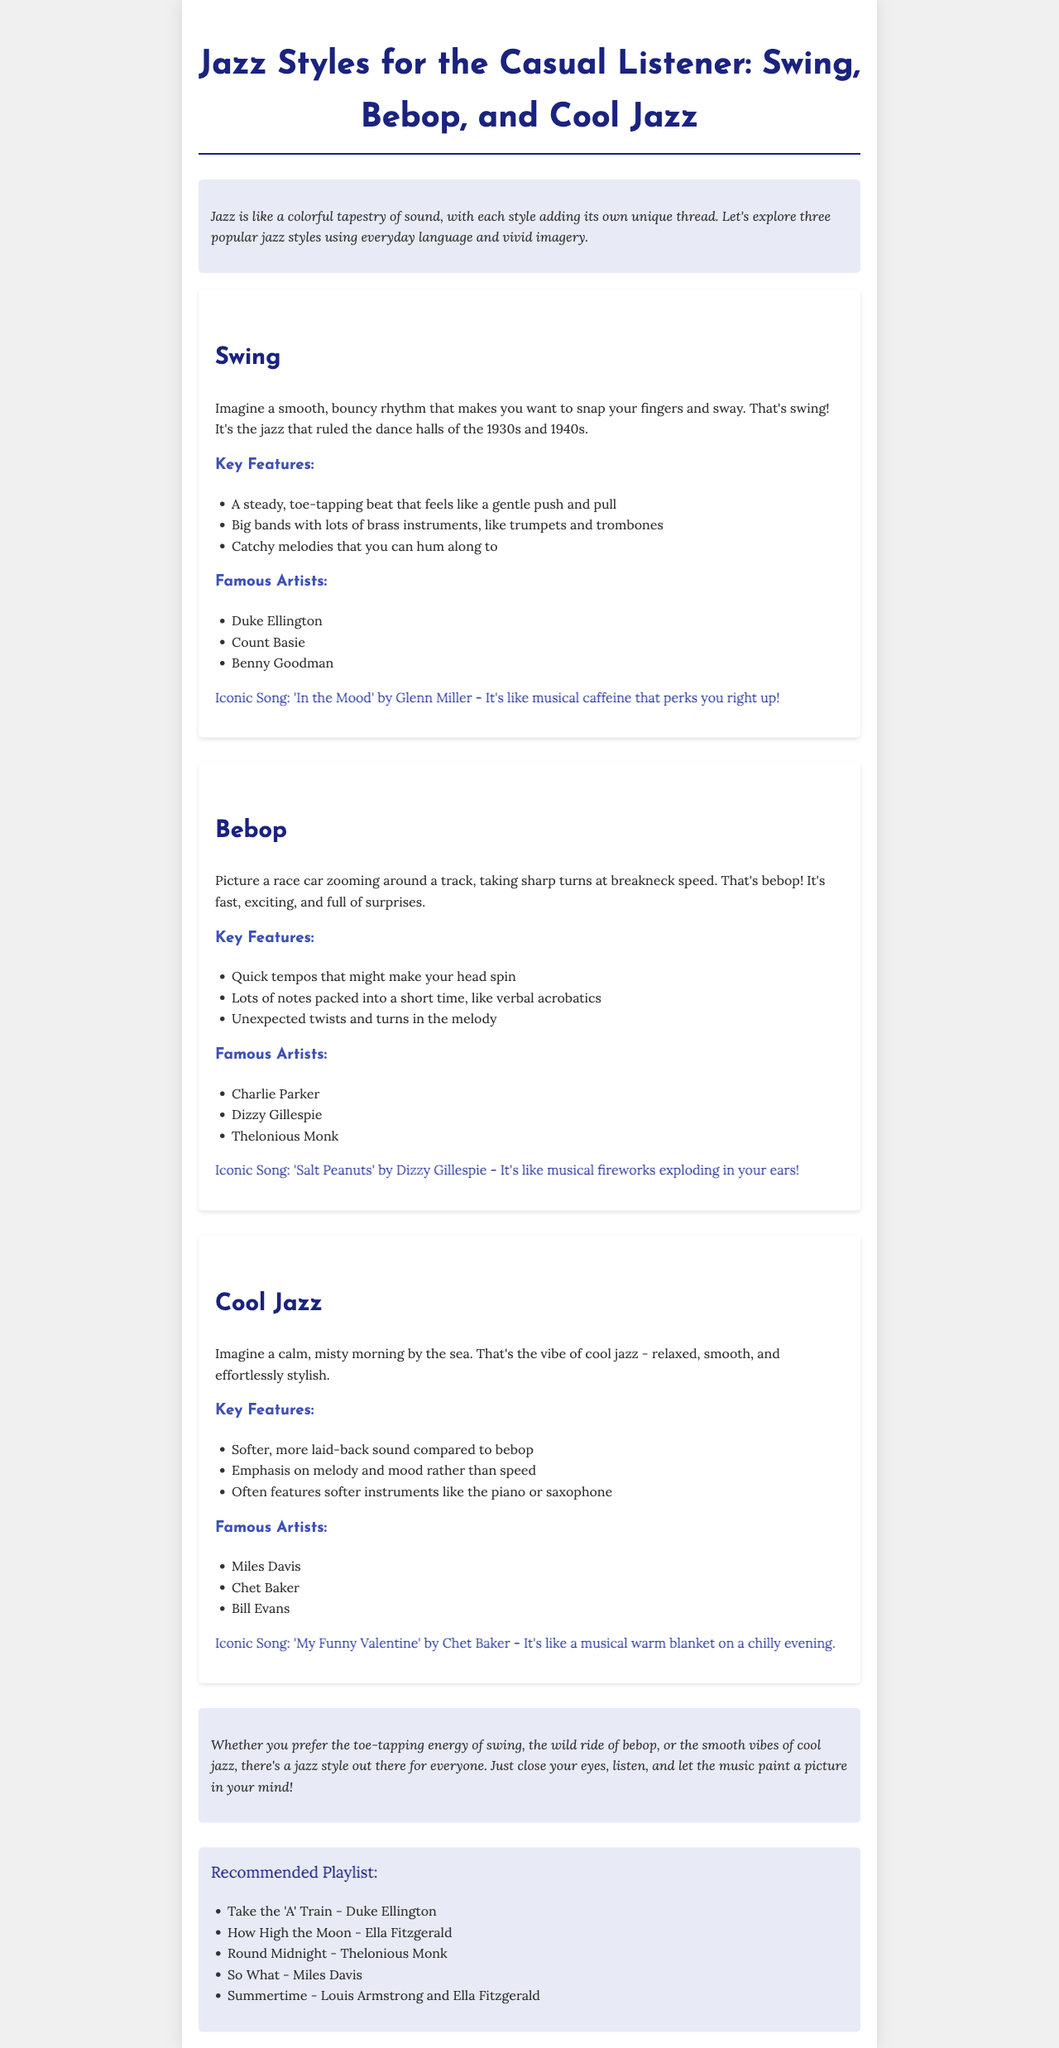What is the title of the brochure? The title is found at the beginning of the document, introducing the topic discussed.
Answer: Jazz Styles for the Casual Listener: Swing, Bebop, and Cool Jazz Which jazz style is described with a smooth, bouncy rhythm? This information is in the section about one of the jazz styles, highlighting its unique rhythm.
Answer: Swing Who is a famous artist associated with bebop? This can be found in the famous artists section of the bebop description, listing prominent figures in this style.
Answer: Charlie Parker What kind of sound does cool jazz have? The document explains the characteristics of cool jazz, particularly its mood and ambience.
Answer: Relaxed, smooth What iconic song is mentioned for swing jazz? This is noted in the swing section as a notable piece representative of that style.
Answer: 'In the Mood' by Glenn Miller How many jazz styles are covered in the brochure? This can be inferred from the sections listed in the document.
Answer: Three What did it compare bebop to in description? The description uses a vivid analogy to convey the energy of bebop.
Answer: A race car zooming around a track Which instrument is emphasized in cool jazz? This detail is found in the key features of the cool jazz section, highlighting its sound.
Answer: Piano or saxophone What is the concluding message about jazz? The conclusion summarizes feelings and experiences related to the different styles of jazz music.
Answer: There's a jazz style out there for everyone 